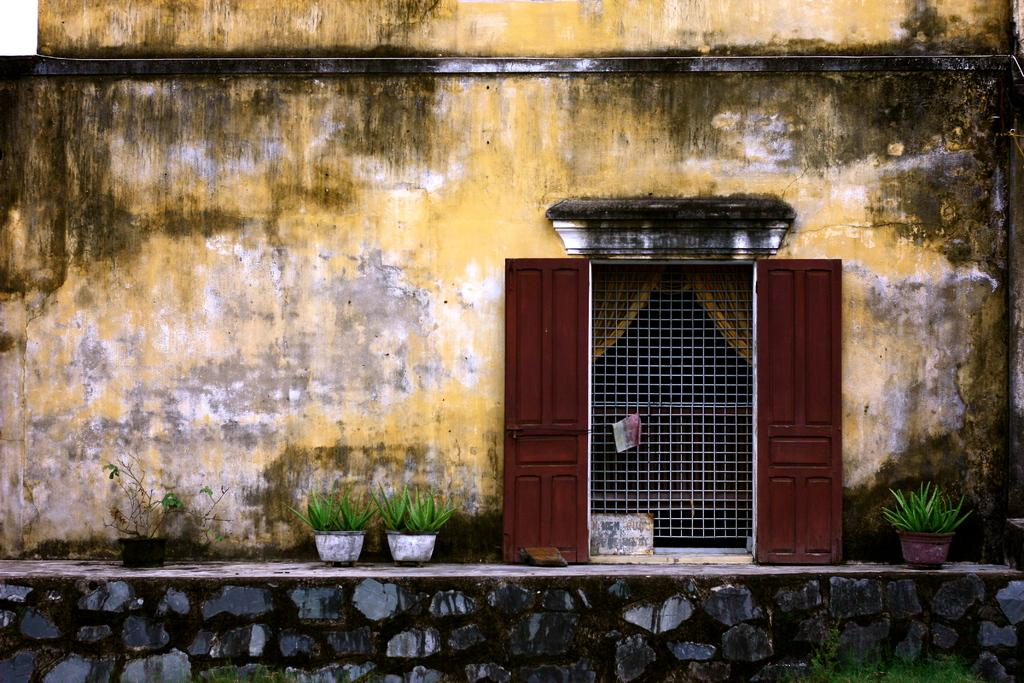What type of structure is visible in the image? There is a building in the image. Where is the gate located in the image? The gate is on the right side of the image. What other entrance can be seen on the right side of the image? There is a door on the right side of the image. What type of vegetation is present in the image? There are plants in the image. What part of the natural environment is visible in the image? The sky is visible in the top left corner of the image. How many horses are visible in the image? There are no horses present in the image. What type of division is shown between the building and the plants in the image? There is no division between the building and the plants in the image; they are simply located next to each other. 